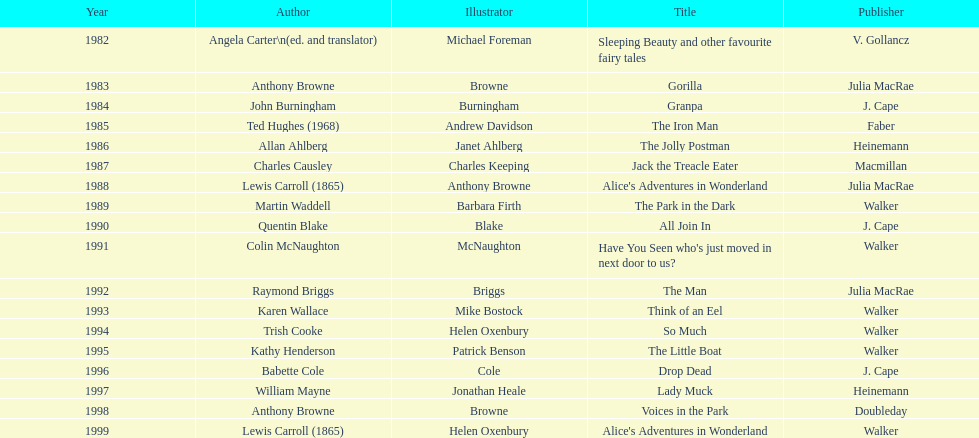Which book won the award a total of 2 times? Alice's Adventures in Wonderland. 